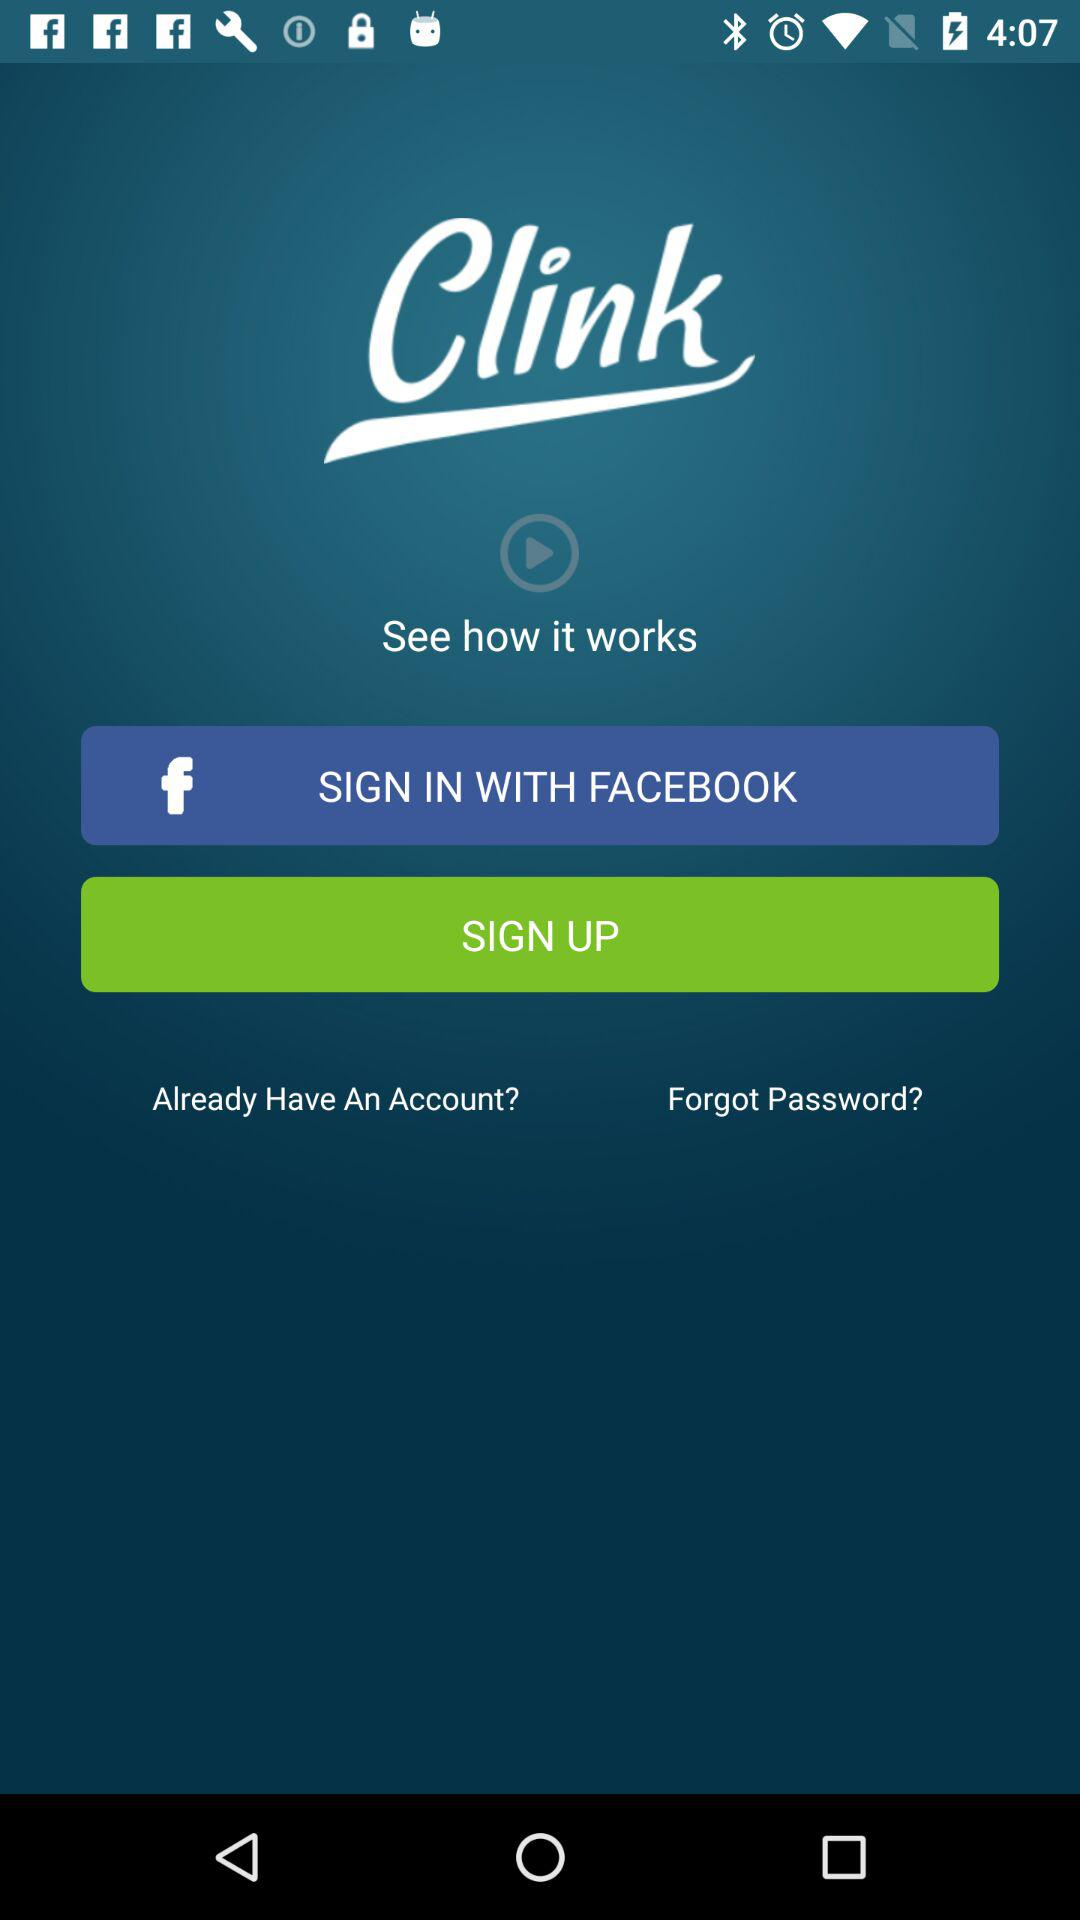What other applications can be used to sign in to the profile? The other applications is "FACEBOOK". 